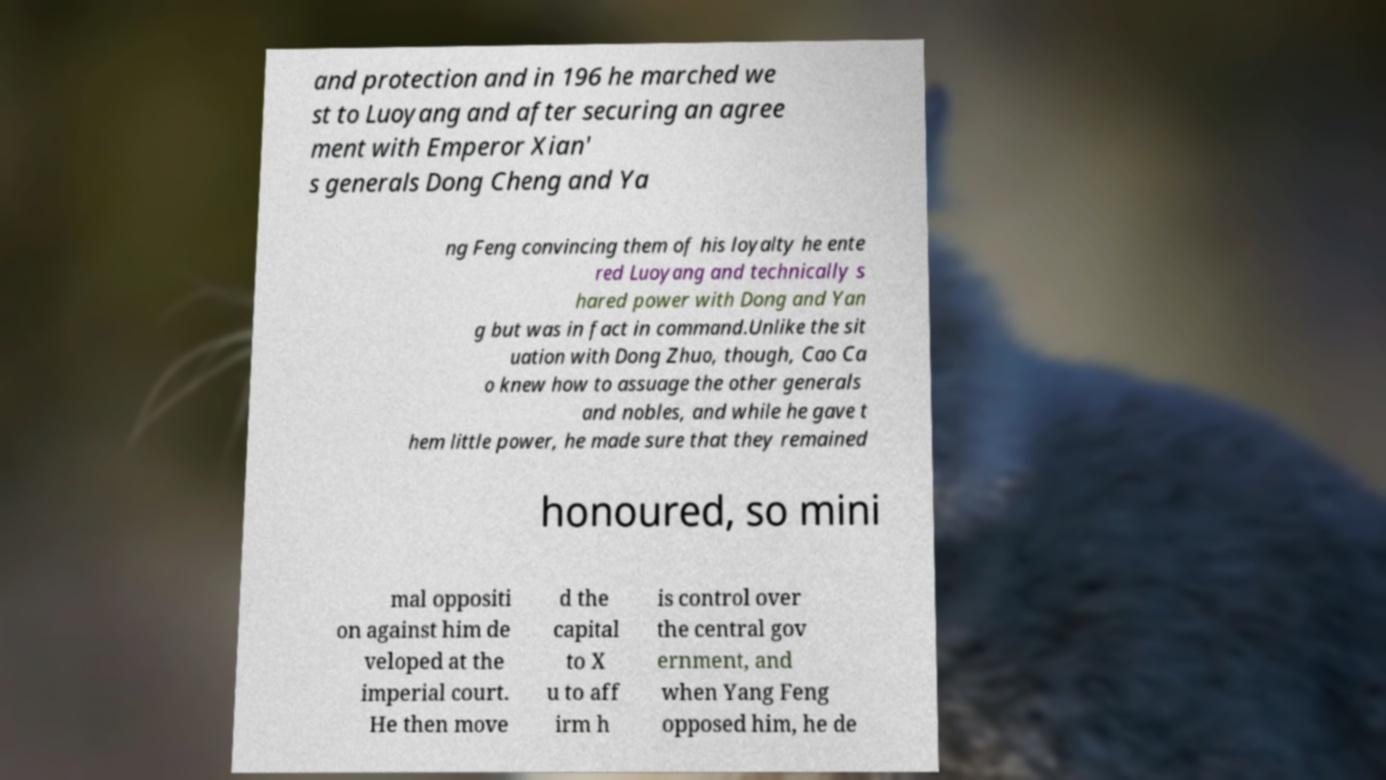Please read and relay the text visible in this image. What does it say? and protection and in 196 he marched we st to Luoyang and after securing an agree ment with Emperor Xian' s generals Dong Cheng and Ya ng Feng convincing them of his loyalty he ente red Luoyang and technically s hared power with Dong and Yan g but was in fact in command.Unlike the sit uation with Dong Zhuo, though, Cao Ca o knew how to assuage the other generals and nobles, and while he gave t hem little power, he made sure that they remained honoured, so mini mal oppositi on against him de veloped at the imperial court. He then move d the capital to X u to aff irm h is control over the central gov ernment, and when Yang Feng opposed him, he de 